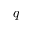<formula> <loc_0><loc_0><loc_500><loc_500>q</formula> 